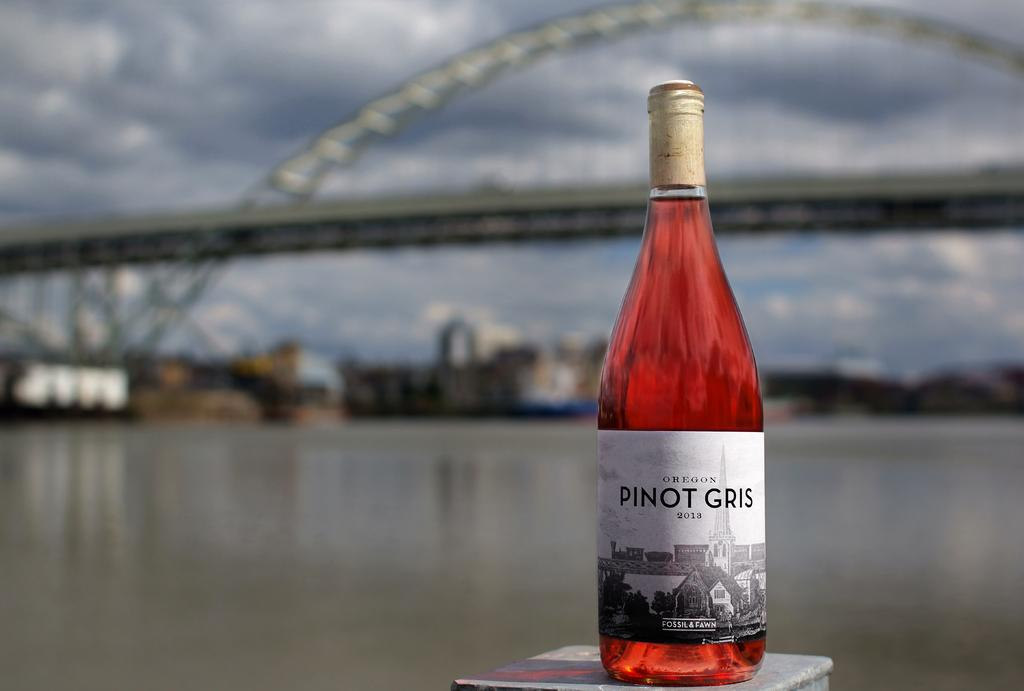Provide a one-sentence caption for the provided image. A bottle of Pinot Gris with a bridge in the background. 